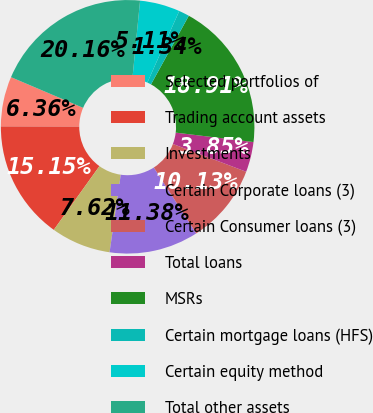<chart> <loc_0><loc_0><loc_500><loc_500><pie_chart><fcel>Selected portfolios of<fcel>Trading account assets<fcel>Investments<fcel>Certain Corporate loans (3)<fcel>Certain Consumer loans (3)<fcel>Total loans<fcel>MSRs<fcel>Certain mortgage loans (HFS)<fcel>Certain equity method<fcel>Total other assets<nl><fcel>6.36%<fcel>15.15%<fcel>7.62%<fcel>11.38%<fcel>10.13%<fcel>3.85%<fcel>18.91%<fcel>1.34%<fcel>5.11%<fcel>20.16%<nl></chart> 